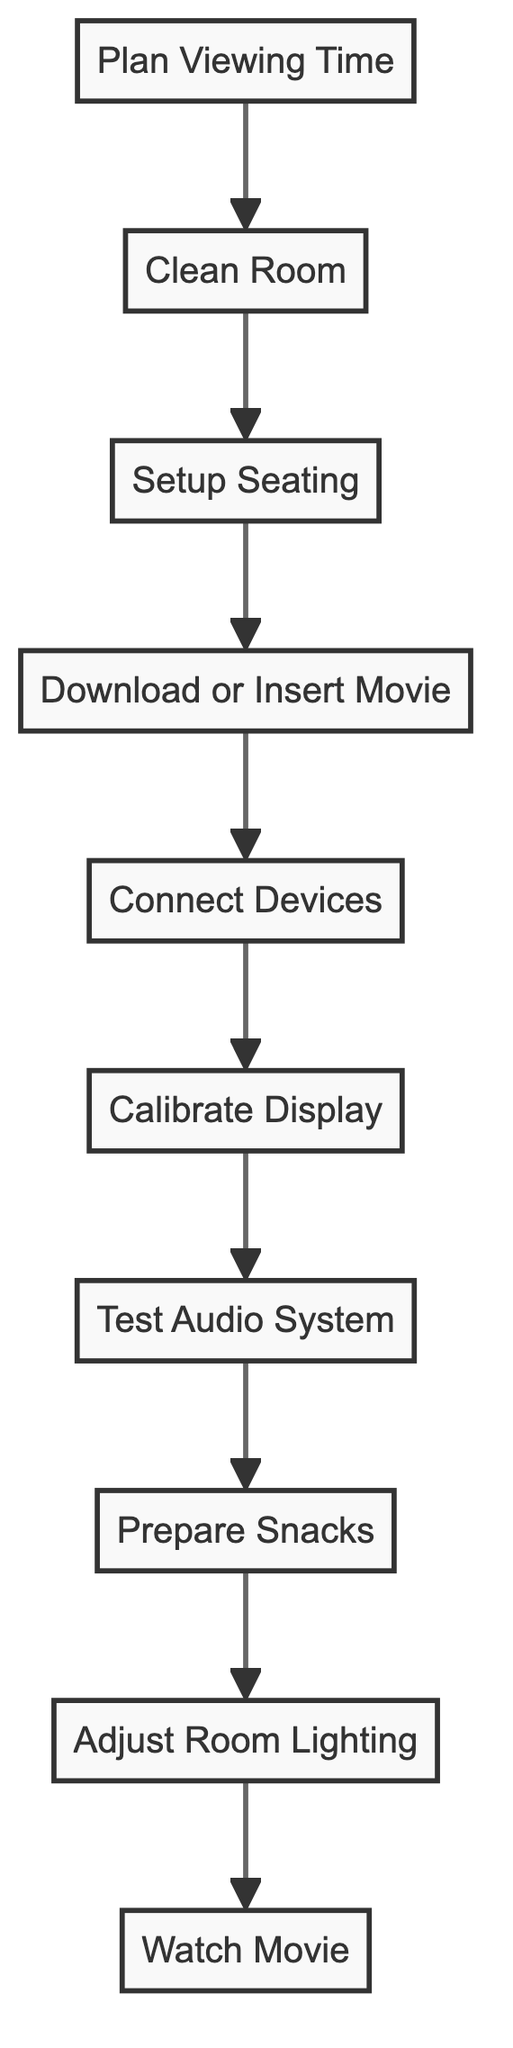What is the last activity before watching the movie? The last activity according to the flow is "Adjust Room Lighting," which directly leads to "Watch Movie." Thus, the final preparatory step is adjusting the lighting to enhance the viewing experience.
Answer: Adjust Room Lighting How many total activities are there in the flow chart? By counting each distinct node in the flow chart, there are ten activities listed that contribute to setting up the home theater experience.
Answer: 10 Which activity comes immediately after preparing snacks? The activity immediately following "Prepare Snacks" is "Test Audio System." This means the next step after snacks is checking the audio setup.
Answer: Test Audio System What is the first activity in the flow leading to the movie? The first step in the flow is "Plan Viewing Time," indicating that organizing a time for the movie is the initial step before any other preparations.
Answer: Plan Viewing Time What activity must be completed before connecting devices? Prior to "Connect Devices," the previous activity is "Download or Insert Movie." This shows that the movie needs to be obtained before connecting the playback devices.
Answer: Download or Insert Movie Which two activities are related by a direct connection? One of the pairs connected directly is "Setup Seating" and "Download or Insert Movie." This indicates a sequential relationship between arranging seating and obtaining the movie.
Answer: Setup Seating and Download or Insert Movie What is the relationship between "Calibrate Display" and "Test Audio System"? The relationship is sequential; "Calibrate Display" follows "Connect Devices," which is also before "Test Audio System." Both are essential steps for ensuring video and audio quality.
Answer: Sequential Which activity requires preparing something before watching the movie? "Prepare Snacks" is the activity that involves preparation before enjoying the movie, indicating it is necessary for an enjoyable viewing experience.
Answer: Prepare Snacks How many activities directly lead to the movie watching step? There are three activities that directly precede "Watch Movie": "Adjust Room Lighting," "Prepare Snacks," and "Test Audio System," representing key final checks before viewing.
Answer: 3 